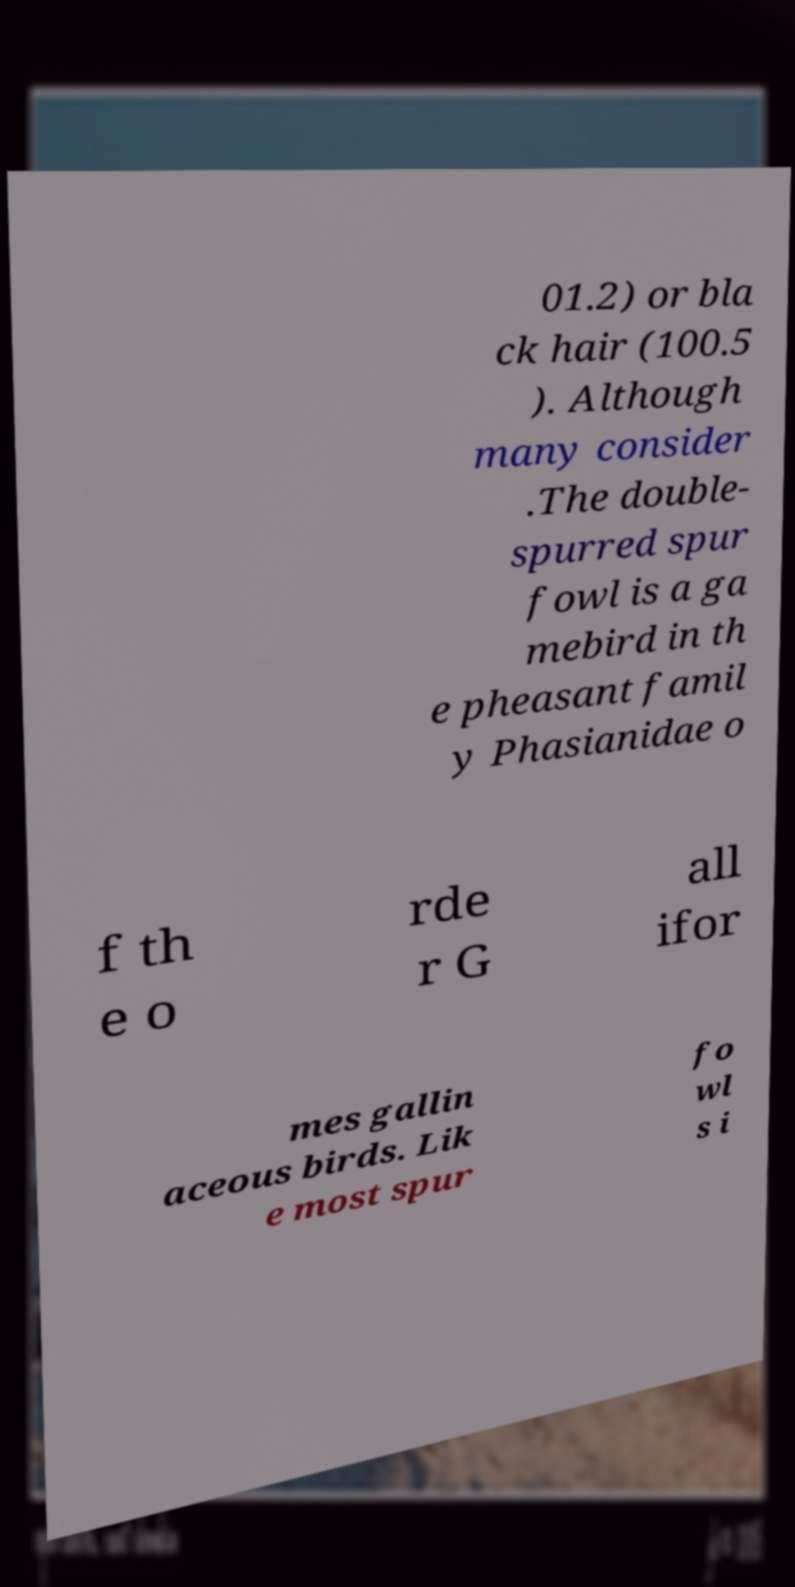Please identify and transcribe the text found in this image. 01.2) or bla ck hair (100.5 ). Although many consider .The double- spurred spur fowl is a ga mebird in th e pheasant famil y Phasianidae o f th e o rde r G all ifor mes gallin aceous birds. Lik e most spur fo wl s i 